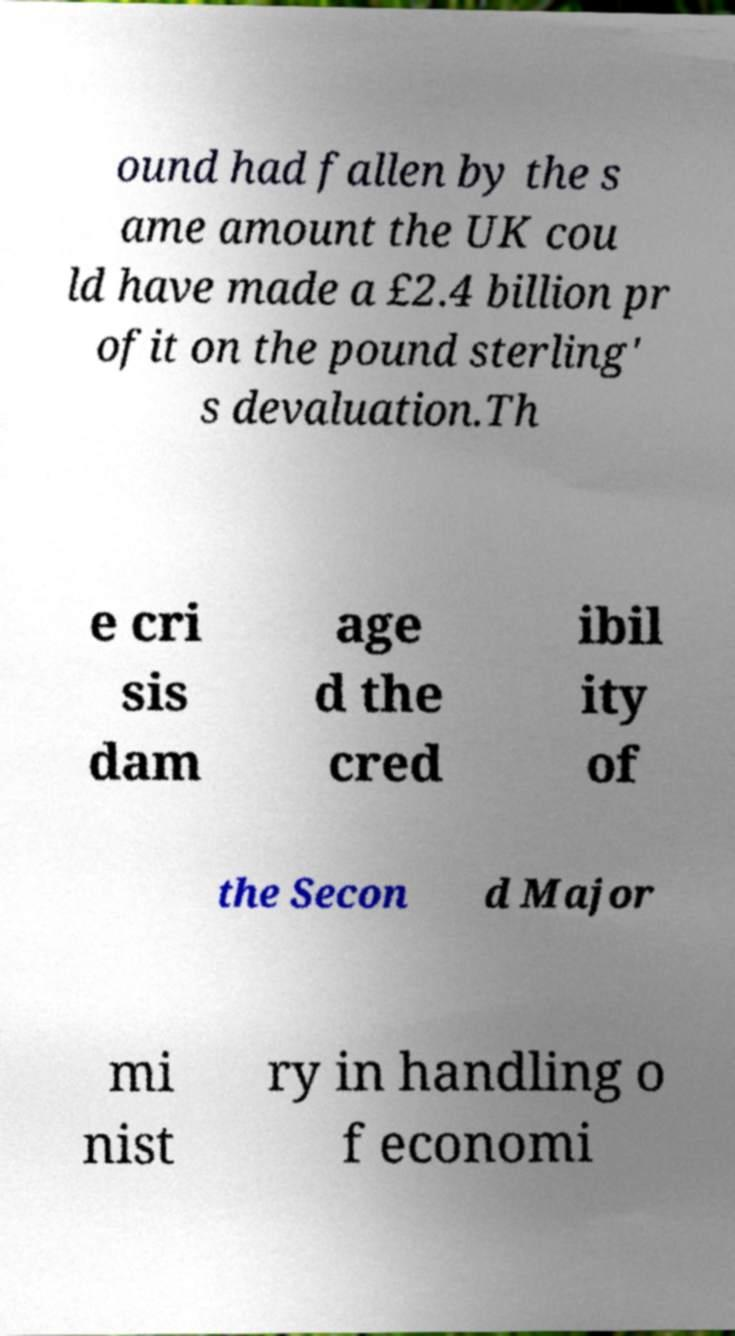I need the written content from this picture converted into text. Can you do that? ound had fallen by the s ame amount the UK cou ld have made a £2.4 billion pr ofit on the pound sterling' s devaluation.Th e cri sis dam age d the cred ibil ity of the Secon d Major mi nist ry in handling o f economi 